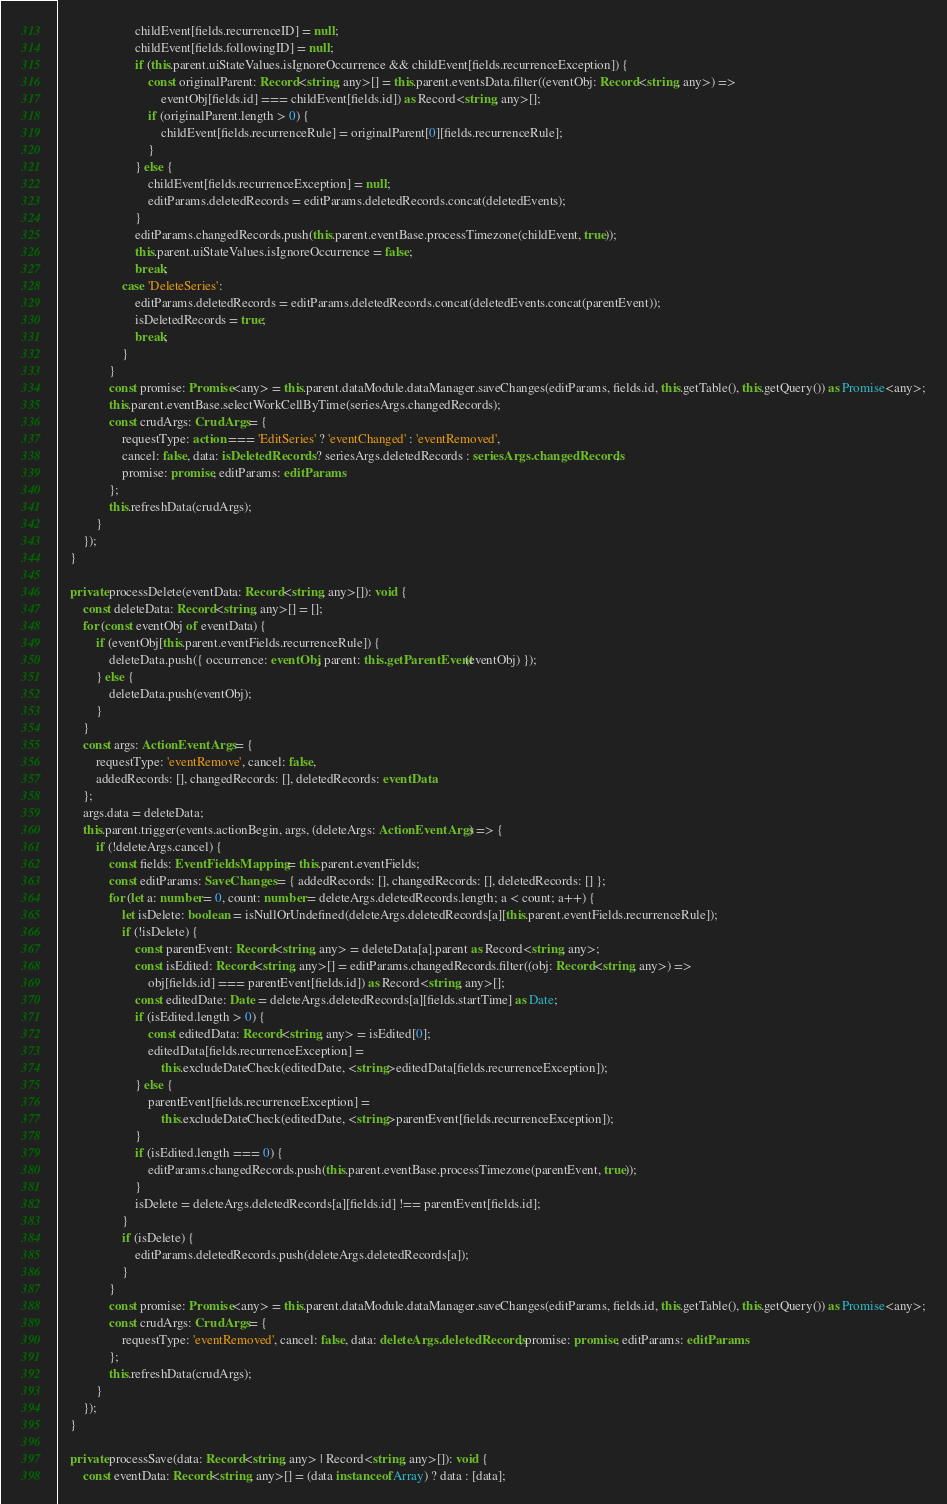Convert code to text. <code><loc_0><loc_0><loc_500><loc_500><_TypeScript_>                        childEvent[fields.recurrenceID] = null;
                        childEvent[fields.followingID] = null;
                        if (this.parent.uiStateValues.isIgnoreOccurrence && childEvent[fields.recurrenceException]) {
                            const originalParent: Record<string, any>[] = this.parent.eventsData.filter((eventObj: Record<string, any>) =>
                                eventObj[fields.id] === childEvent[fields.id]) as Record<string, any>[];
                            if (originalParent.length > 0) {
                                childEvent[fields.recurrenceRule] = originalParent[0][fields.recurrenceRule];
                            }
                        } else {
                            childEvent[fields.recurrenceException] = null;
                            editParams.deletedRecords = editParams.deletedRecords.concat(deletedEvents);
                        }
                        editParams.changedRecords.push(this.parent.eventBase.processTimezone(childEvent, true));
                        this.parent.uiStateValues.isIgnoreOccurrence = false;
                        break;
                    case 'DeleteSeries':
                        editParams.deletedRecords = editParams.deletedRecords.concat(deletedEvents.concat(parentEvent));
                        isDeletedRecords = true;
                        break;
                    }
                }
                const promise: Promise<any> = this.parent.dataModule.dataManager.saveChanges(editParams, fields.id, this.getTable(), this.getQuery()) as Promise<any>;
                this.parent.eventBase.selectWorkCellByTime(seriesArgs.changedRecords);
                const crudArgs: CrudArgs = {
                    requestType: action === 'EditSeries' ? 'eventChanged' : 'eventRemoved',
                    cancel: false, data: isDeletedRecords ? seriesArgs.deletedRecords : seriesArgs.changedRecords,
                    promise: promise, editParams: editParams
                };
                this.refreshData(crudArgs);
            }
        });
    }

    private processDelete(eventData: Record<string, any>[]): void {
        const deleteData: Record<string, any>[] = [];
        for (const eventObj of eventData) {
            if (eventObj[this.parent.eventFields.recurrenceRule]) {
                deleteData.push({ occurrence: eventObj, parent: this.getParentEvent(eventObj) });
            } else {
                deleteData.push(eventObj);
            }
        }
        const args: ActionEventArgs = {
            requestType: 'eventRemove', cancel: false,
            addedRecords: [], changedRecords: [], deletedRecords: eventData
        };
        args.data = deleteData;
        this.parent.trigger(events.actionBegin, args, (deleteArgs: ActionEventArgs) => {
            if (!deleteArgs.cancel) {
                const fields: EventFieldsMapping = this.parent.eventFields;
                const editParams: SaveChanges = { addedRecords: [], changedRecords: [], deletedRecords: [] };
                for (let a: number = 0, count: number = deleteArgs.deletedRecords.length; a < count; a++) {
                    let isDelete: boolean = isNullOrUndefined(deleteArgs.deletedRecords[a][this.parent.eventFields.recurrenceRule]);
                    if (!isDelete) {
                        const parentEvent: Record<string, any> = deleteData[a].parent as Record<string, any>;
                        const isEdited: Record<string, any>[] = editParams.changedRecords.filter((obj: Record<string, any>) =>
                            obj[fields.id] === parentEvent[fields.id]) as Record<string, any>[];
                        const editedDate: Date = deleteArgs.deletedRecords[a][fields.startTime] as Date;
                        if (isEdited.length > 0) {
                            const editedData: Record<string, any> = isEdited[0];
                            editedData[fields.recurrenceException] =
                                this.excludeDateCheck(editedDate, <string>editedData[fields.recurrenceException]);
                        } else {
                            parentEvent[fields.recurrenceException] =
                                this.excludeDateCheck(editedDate, <string>parentEvent[fields.recurrenceException]);
                        }
                        if (isEdited.length === 0) {
                            editParams.changedRecords.push(this.parent.eventBase.processTimezone(parentEvent, true));
                        }
                        isDelete = deleteArgs.deletedRecords[a][fields.id] !== parentEvent[fields.id];
                    }
                    if (isDelete) {
                        editParams.deletedRecords.push(deleteArgs.deletedRecords[a]);
                    }
                }
                const promise: Promise<any> = this.parent.dataModule.dataManager.saveChanges(editParams, fields.id, this.getTable(), this.getQuery()) as Promise<any>;
                const crudArgs: CrudArgs = {
                    requestType: 'eventRemoved', cancel: false, data: deleteArgs.deletedRecords, promise: promise, editParams: editParams
                };
                this.refreshData(crudArgs);
            }
        });
    }

    private processSave(data: Record<string, any> | Record<string, any>[]): void {
        const eventData: Record<string, any>[] = (data instanceof Array) ? data : [data];</code> 